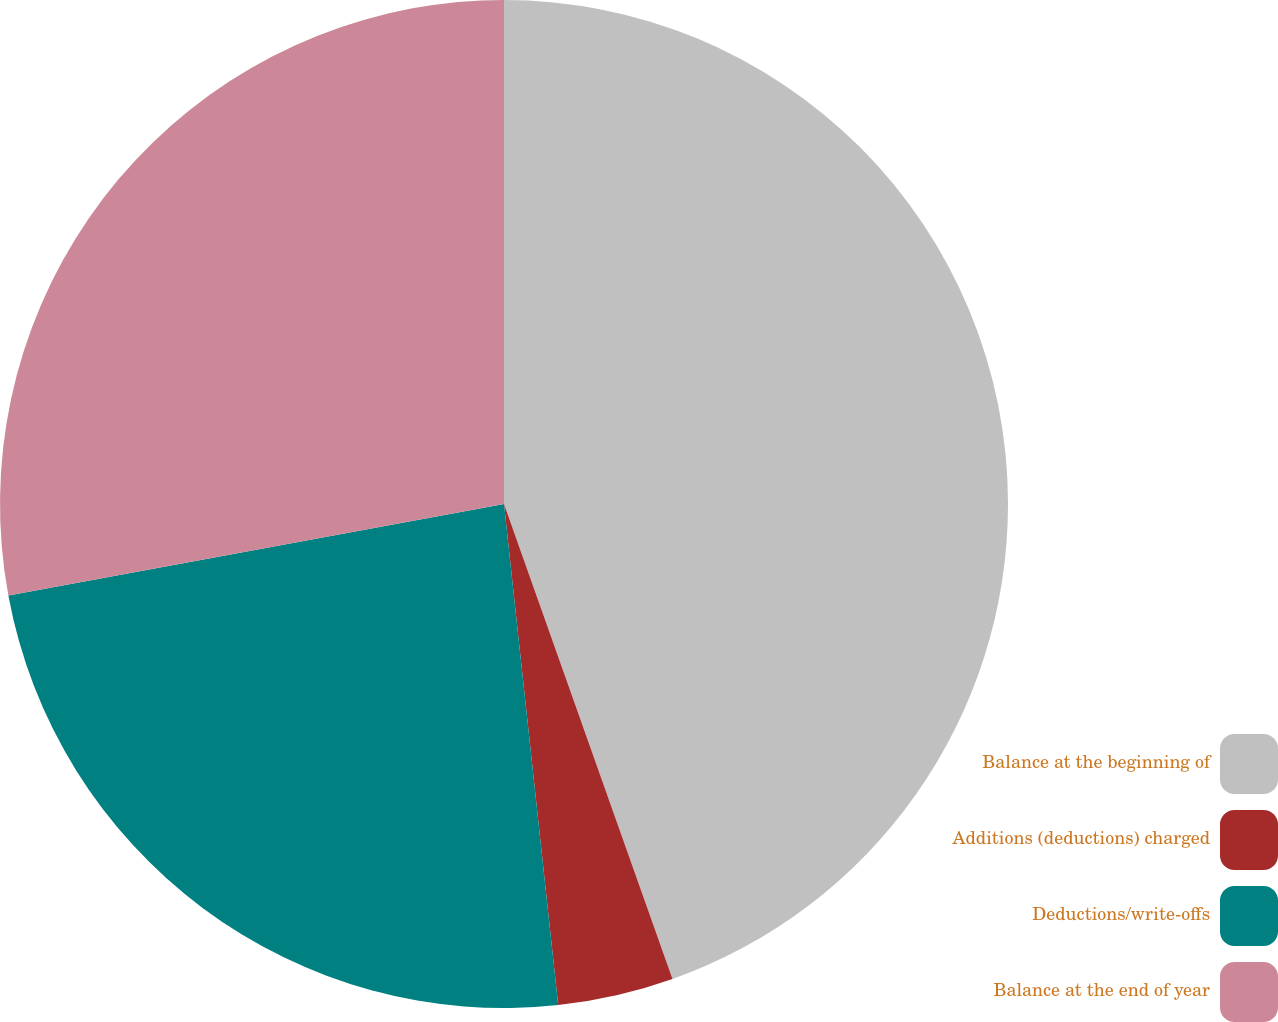Convert chart to OTSL. <chart><loc_0><loc_0><loc_500><loc_500><pie_chart><fcel>Balance at the beginning of<fcel>Additions (deductions) charged<fcel>Deductions/write-offs<fcel>Balance at the end of year<nl><fcel>44.57%<fcel>3.71%<fcel>23.81%<fcel>27.9%<nl></chart> 